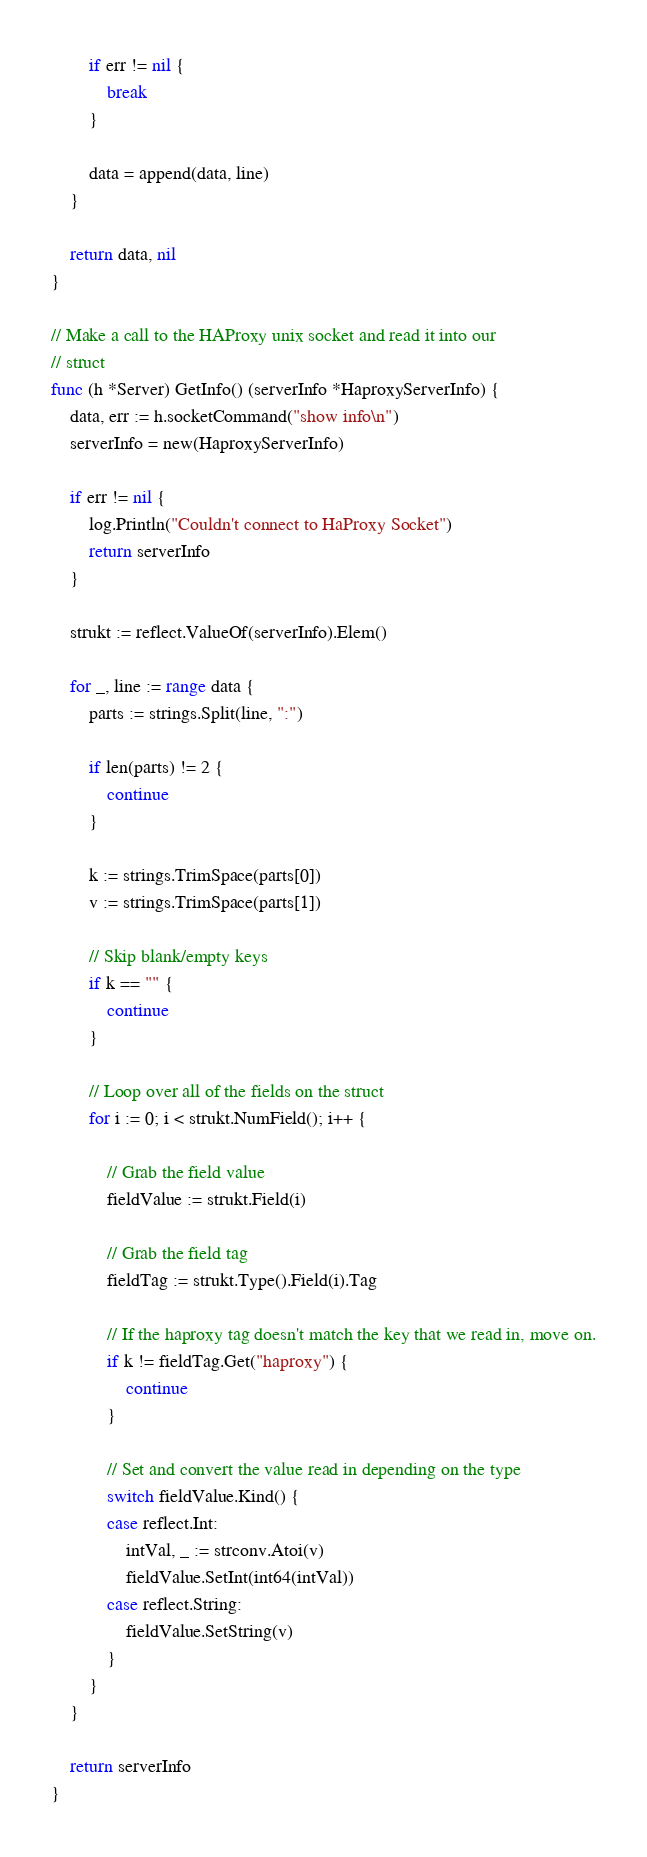Convert code to text. <code><loc_0><loc_0><loc_500><loc_500><_Go_>		if err != nil {
			break
		}

		data = append(data, line)
	}

	return data, nil
}

// Make a call to the HAProxy unix socket and read it into our
// struct
func (h *Server) GetInfo() (serverInfo *HaproxyServerInfo) {
	data, err := h.socketCommand("show info\n")
	serverInfo = new(HaproxyServerInfo)

	if err != nil {
		log.Println("Couldn't connect to HaProxy Socket")
		return serverInfo
	}

	strukt := reflect.ValueOf(serverInfo).Elem()

	for _, line := range data {
		parts := strings.Split(line, ":")

		if len(parts) != 2 {
			continue
		}

		k := strings.TrimSpace(parts[0])
		v := strings.TrimSpace(parts[1])

		// Skip blank/empty keys
		if k == "" {
			continue
		}

		// Loop over all of the fields on the struct
		for i := 0; i < strukt.NumField(); i++ {

			// Grab the field value
			fieldValue := strukt.Field(i)

			// Grab the field tag
			fieldTag := strukt.Type().Field(i).Tag

			// If the haproxy tag doesn't match the key that we read in, move on.
			if k != fieldTag.Get("haproxy") {
				continue
			}

			// Set and convert the value read in depending on the type
			switch fieldValue.Kind() {
			case reflect.Int:
				intVal, _ := strconv.Atoi(v)
				fieldValue.SetInt(int64(intVal))
			case reflect.String:
				fieldValue.SetString(v)
			}
		}
	}

	return serverInfo
}
</code> 